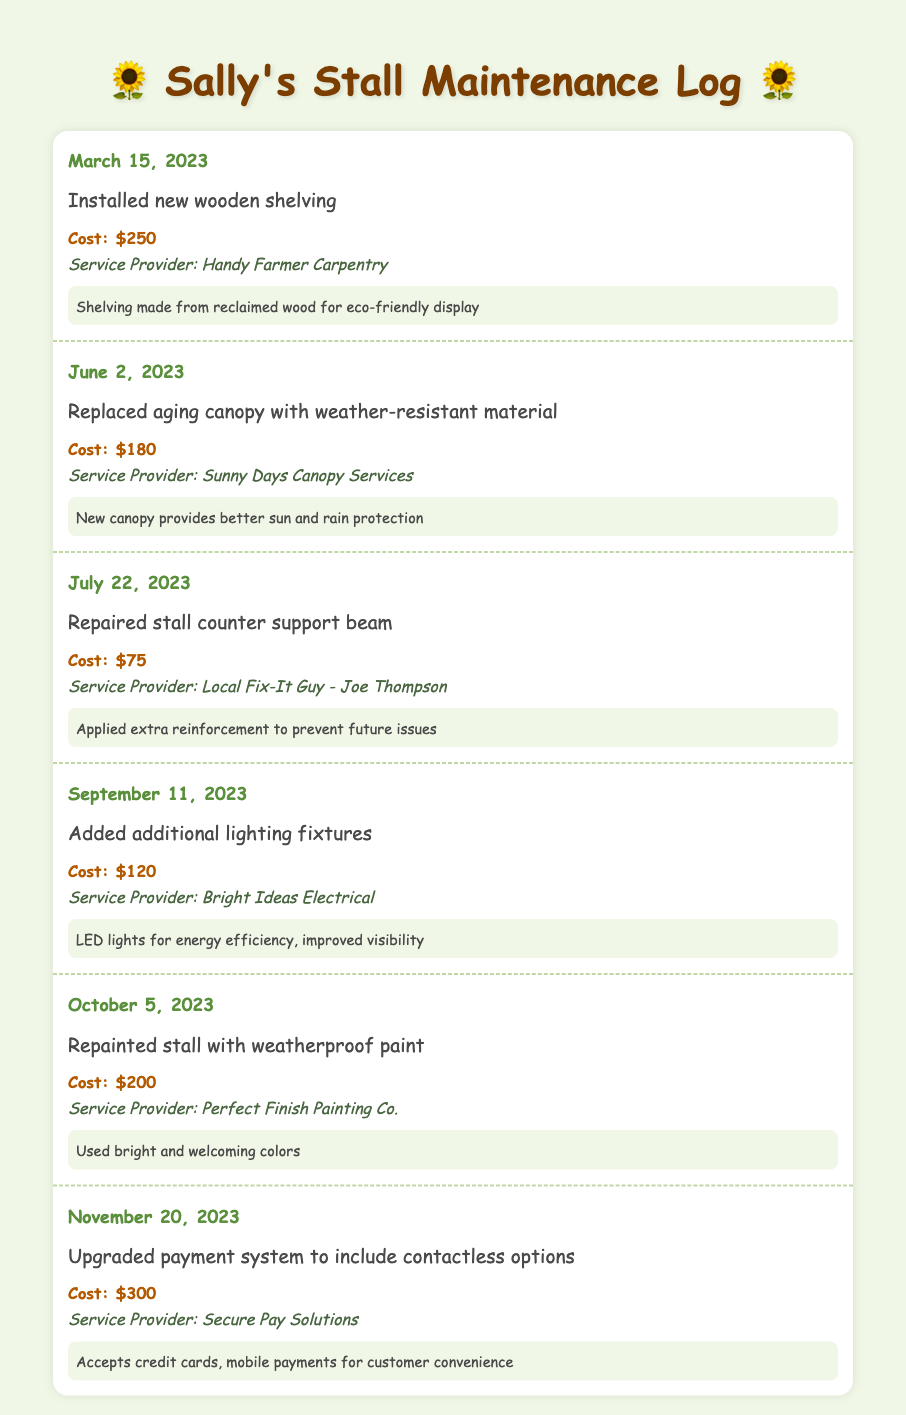what date was the last maintenance item recorded? The last entry is dated November 20, 2023, according to the log.
Answer: November 20, 2023 how much did the shelving installation cost? The cost for the installation of new wooden shelving is recorded as $250.
Answer: $250 who provided the service for converting the payment system? The service for upgrading the payment system was provided by Secure Pay Solutions.
Answer: Secure Pay Solutions what type of material was used for the new canopy? The new canopy is made from weather-resistant material, as stated in the entry.
Answer: weather-resistant material how many repairs or upgrades occurred in 2023? The log lists a total of five maintenance entries in the year 2023.
Answer: five what was the cost of the lighting upgrade? The cost of adding additional lighting fixtures is specified as $120 in the log.
Answer: $120 which provider was responsible for repainting the stall? The repainting of the stall was carried out by Perfect Finish Painting Co.
Answer: Perfect Finish Painting Co what renewable feature was mentioned in the new shelving installation? The entry states that the shelving was made from reclaimed wood, indicating its eco-friendly feature.
Answer: reclaimed wood which service provided the best sun and rain protection? The newly replaced canopy, according to the log entry, provides better sun and rain protection.
Answer: new canopy 